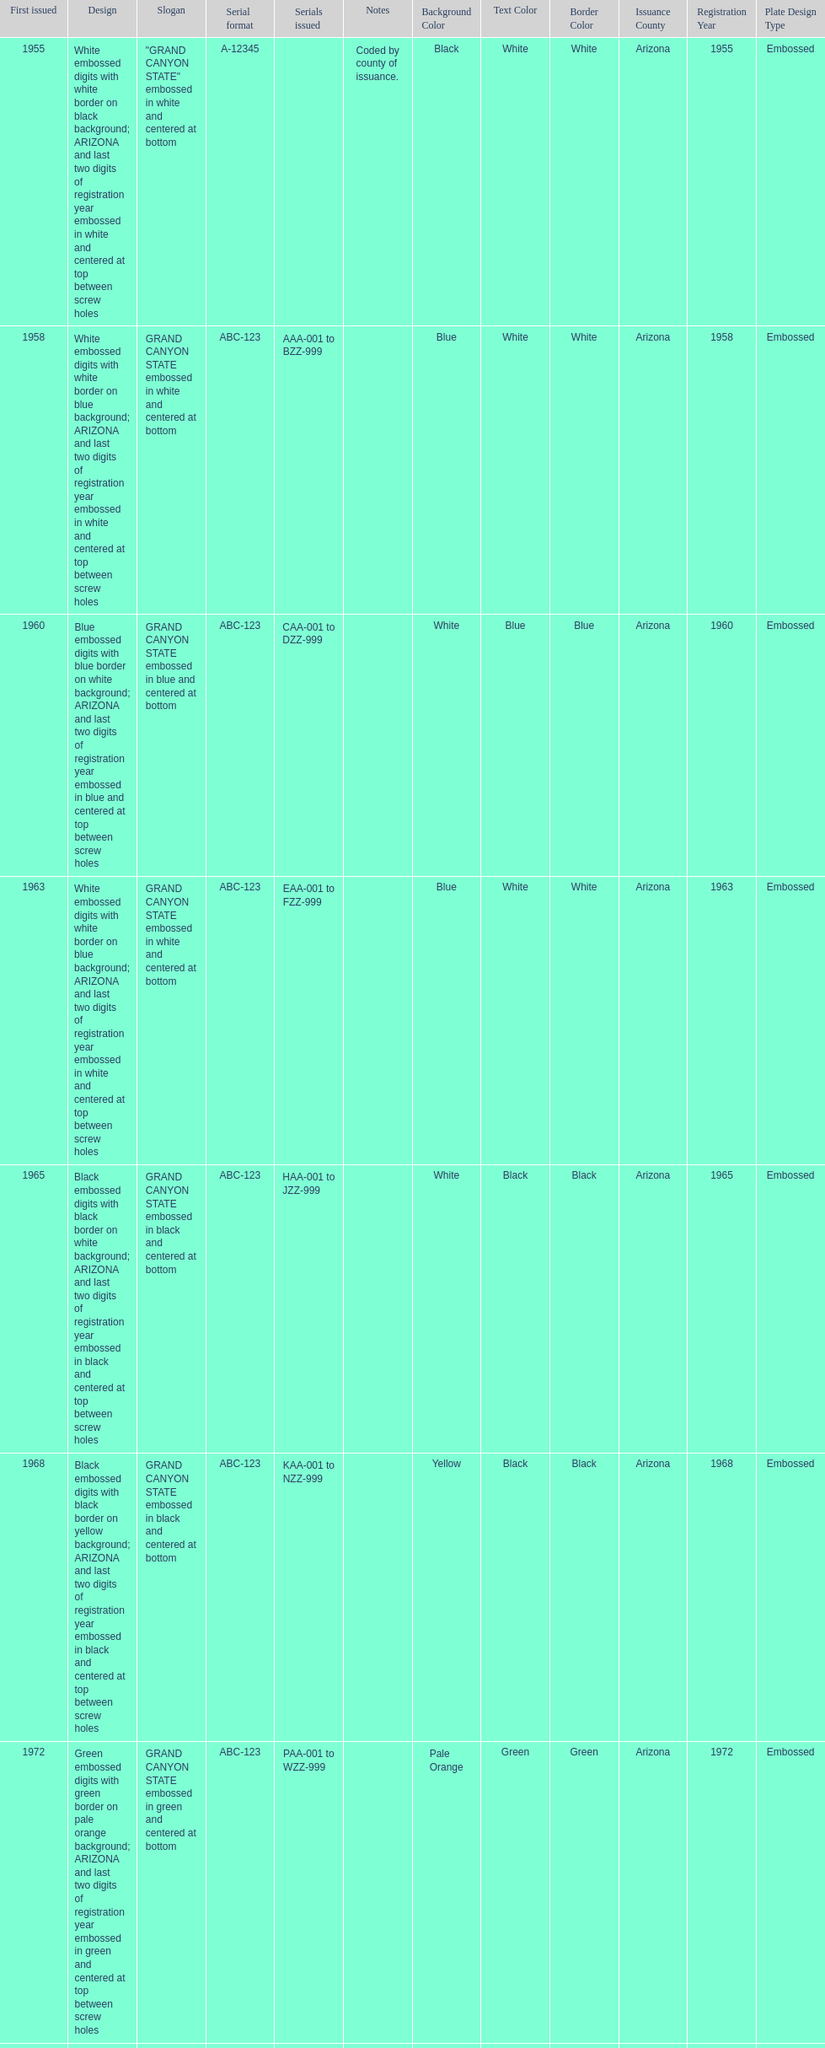Help me parse the entirety of this table. {'header': ['First issued', 'Design', 'Slogan', 'Serial format', 'Serials issued', 'Notes', 'Background Color', 'Text Color', 'Border Color', 'Issuance County', 'Registration Year', 'Plate Design Type'], 'rows': [['1955', 'White embossed digits with white border on black background; ARIZONA and last two digits of registration year embossed in white and centered at top between screw holes', '"GRAND CANYON STATE" embossed in white and centered at bottom', 'A-12345', '', 'Coded by county of issuance.', 'Black', 'White', 'White', 'Arizona', '1955', 'Embossed'], ['1958', 'White embossed digits with white border on blue background; ARIZONA and last two digits of registration year embossed in white and centered at top between screw holes', 'GRAND CANYON STATE embossed in white and centered at bottom', 'ABC-123', 'AAA-001 to BZZ-999', '', 'Blue', 'White', 'White', 'Arizona', '1958', 'Embossed'], ['1960', 'Blue embossed digits with blue border on white background; ARIZONA and last two digits of registration year embossed in blue and centered at top between screw holes', 'GRAND CANYON STATE embossed in blue and centered at bottom', 'ABC-123', 'CAA-001 to DZZ-999', '', 'White', 'Blue', 'Blue', 'Arizona', '1960', 'Embossed'], ['1963', 'White embossed digits with white border on blue background; ARIZONA and last two digits of registration year embossed in white and centered at top between screw holes', 'GRAND CANYON STATE embossed in white and centered at bottom', 'ABC-123', 'EAA-001 to FZZ-999', '', 'Blue', 'White', 'White', 'Arizona', '1963', 'Embossed'], ['1965', 'Black embossed digits with black border on white background; ARIZONA and last two digits of registration year embossed in black and centered at top between screw holes', 'GRAND CANYON STATE embossed in black and centered at bottom', 'ABC-123', 'HAA-001 to JZZ-999', '', 'White', 'Black', 'Black', 'Arizona', '1965', 'Embossed'], ['1968', 'Black embossed digits with black border on yellow background; ARIZONA and last two digits of registration year embossed in black and centered at top between screw holes', 'GRAND CANYON STATE embossed in black and centered at bottom', 'ABC-123', 'KAA-001 to NZZ-999', '', 'Yellow', 'Black', 'Black', 'Arizona', '1968', 'Embossed'], ['1972', 'Green embossed digits with green border on pale orange background; ARIZONA and last two digits of registration year embossed in green and centered at top between screw holes', 'GRAND CANYON STATE embossed in green and centered at bottom', 'ABC-123', 'PAA-001 to WZZ-999', '', 'Pale Orange', 'Green', 'Green', 'Arizona', '1972', 'Embossed'], ['1980', 'White embossed digits with white embossed border on maroon background, with white embossed saguaro cactus dividing the letters and numbers; ARIZONA embossed in white and centered at top', 'GRAND CANYON STATE embossed in white and centered at bottom', 'ABC-123', 'AAA-001 to NZZ-999', '', 'Maroon', 'White', 'White', 'Arizona', '1980', 'Embossed'], ['1996', 'Dark green embossed digits on screened background of purple mountains and cacti with white setting sun and sky fading from orange to white to turquoise at top; ARIZONA in wide plain dark green letters outlined in white and centered at top', 'GRAND CANYON STATE in dark green thin plain letters at bottom right in orange part of screen', '123·ABC', '101·AAA to 999·ZZZ', 'Awarded "Plate of the Year" for best new license plate of 1996 by the Automobile License Plate Collectors Association, the first time Arizona has been so honored.', 'Multicolored', 'Dark Green', 'None', 'Arizona', '1996', 'Screened'], ['2008', 'Dark green screened digits on screened background of purple mountains and cacti with white setting sun and sky fading from orange to white to turquoise at top; ARIZONA in wide plain dark green letters outlined in white and centered at top; security stripe through center of plate', 'GRAND CANYON STATE in dark green thin plain letters at bottom right in orange part of screen', 'ABC1234', 'AAA0001 to present', '', 'Multicolored', 'Dark Green', 'None', 'Arizona', '2008', 'Screened']]} Name the year of the license plate that has the largest amount of alphanumeric digits. 2008. 